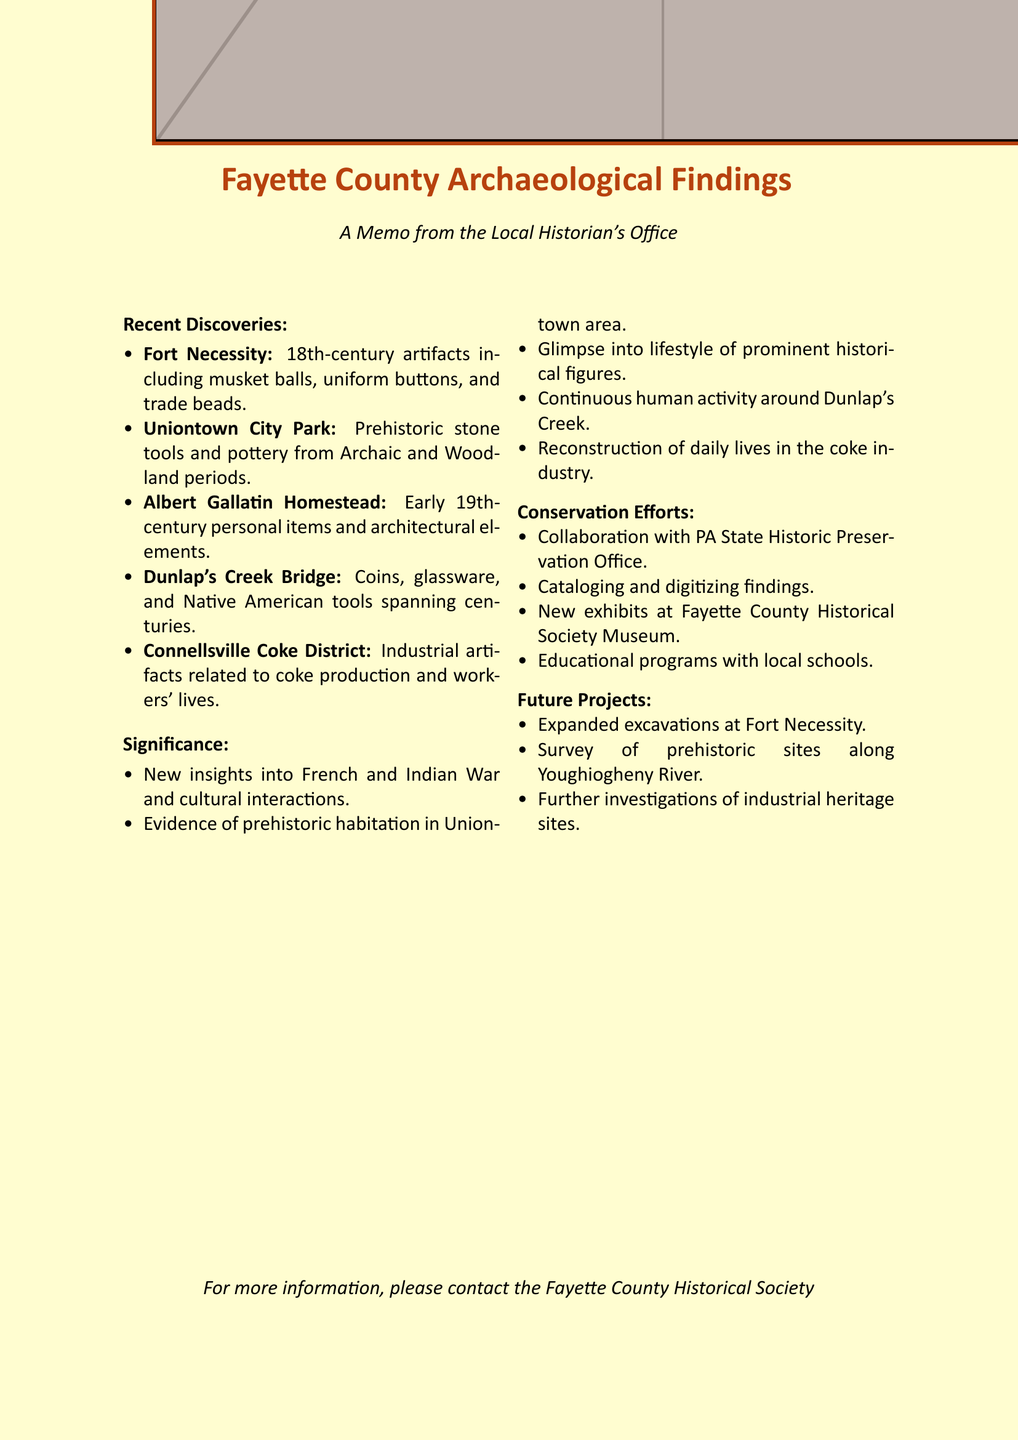What location was surveyed by a team from California University of Pennsylvania? The document states that Uniontown City Park was surveyed by a team from California University of Pennsylvania.
Answer: Uniontown City Park What type of artifacts were found at Fort Necessity? The artifacts found at Fort Necessity include musket balls, lead shot, uniform buttons, trade beads, and colonial ceramics.
Answer: 18th-century artifacts What period do the stone tools from Uniontown City Park date back to? The document mentions that the stone tools and projectile points date back to the Archaic period.
Answer: Archaic period What significant discovery was made at the Albert Gallatin Homestead? The findings at the Albert Gallatin Homestead include personal items of Albert Gallatin and architectural elements of the original mansion.
Answer: Personal items and architectural elements How many future archaeological projects are mentioned in the document? The document lists three future projects that are being planned.
Answer: Three What is the primary goal of the conservation efforts outlined in the memo? The memo states that the goal is to ensure proper conservation and storage of the newly discovered artifacts.
Answer: Proper conservation and storage What evidence was found at Dunlap's Creek Bridge that suggests continuous human activity? The findings at Dunlap's Creek Bridge included Native American stone tools, suggesting long-term use of the creek crossing.
Answer: Native American stone tools What type of items were uncovered in the Connellsville Coke District? The Connellsville Coke District yielded artifacts related to industrial work, including tools and personal items of coke workers.
Answer: Industrial artifacts 